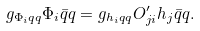<formula> <loc_0><loc_0><loc_500><loc_500>g _ { \Phi _ { i } q q } \Phi _ { i } \bar { q } q = g _ { h _ { i } q q } O ^ { \prime } _ { j i } h _ { j } \bar { q } q .</formula> 